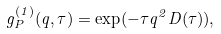<formula> <loc_0><loc_0><loc_500><loc_500>g ^ { ( 1 ) } _ { P } ( q , \tau ) = \exp ( - \tau q ^ { 2 } D ( \tau ) ) ,</formula> 